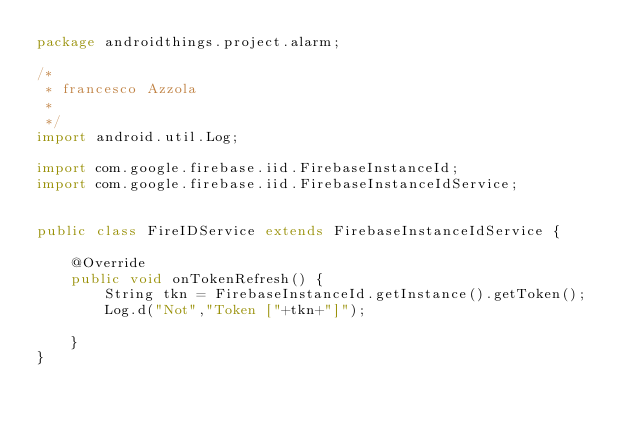<code> <loc_0><loc_0><loc_500><loc_500><_Java_>package androidthings.project.alarm;

/*
 * francesco Azzola
 *
 */
import android.util.Log;

import com.google.firebase.iid.FirebaseInstanceId;
import com.google.firebase.iid.FirebaseInstanceIdService;


public class FireIDService extends FirebaseInstanceIdService {

    @Override
    public void onTokenRefresh() {
        String tkn = FirebaseInstanceId.getInstance().getToken();
        Log.d("Not","Token ["+tkn+"]");

    }
}
</code> 